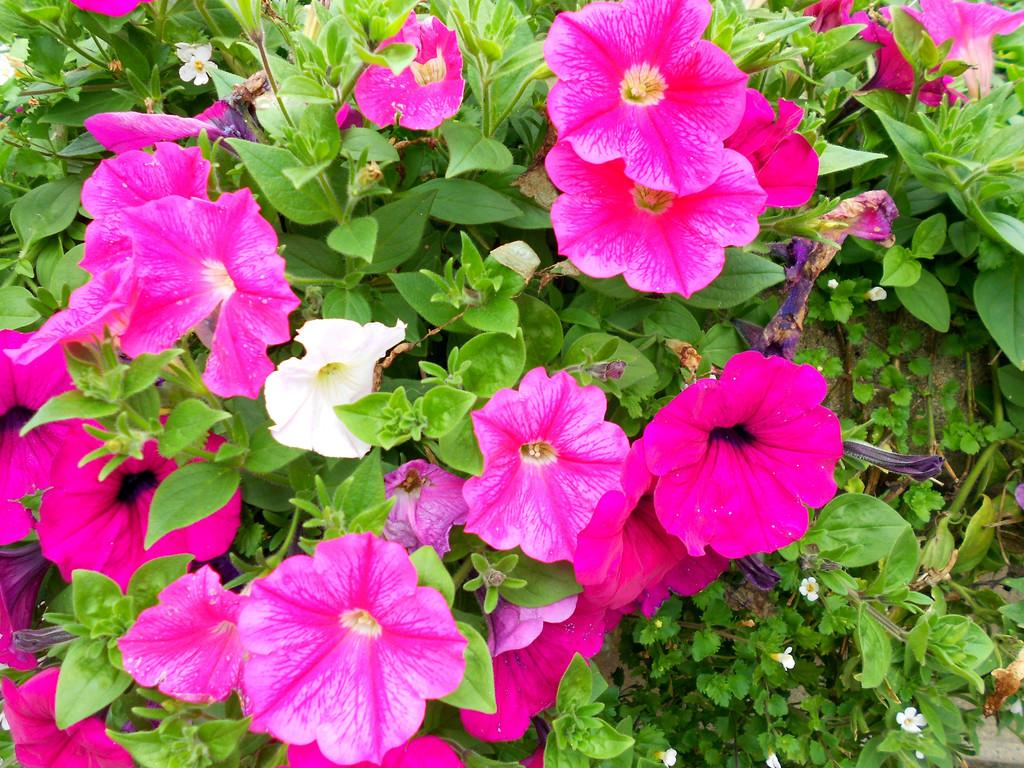What colors are the flowers in the image? The flowers in the image are white and pink. What are the flowers attached to? The flowers are on plants. Can you describe any other part of the plants in the image? There is a leaf visible in the image. What type of soap is being used to clean the roof in the image? There is no soap or roof present in the image; it features white and pink flowers on plants with a visible leaf. 